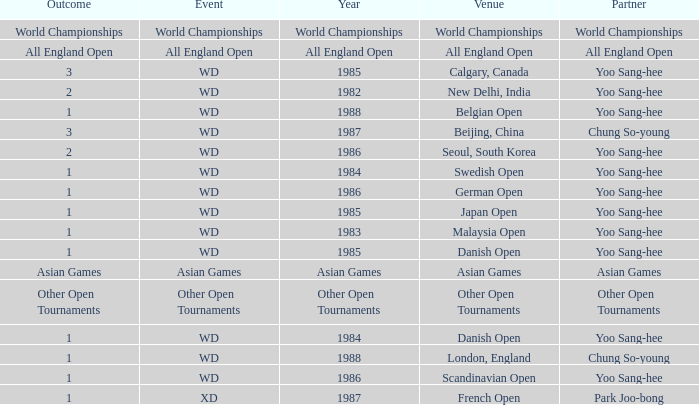In what Year did the German Open have Yoo Sang-Hee as Partner? 1986.0. 